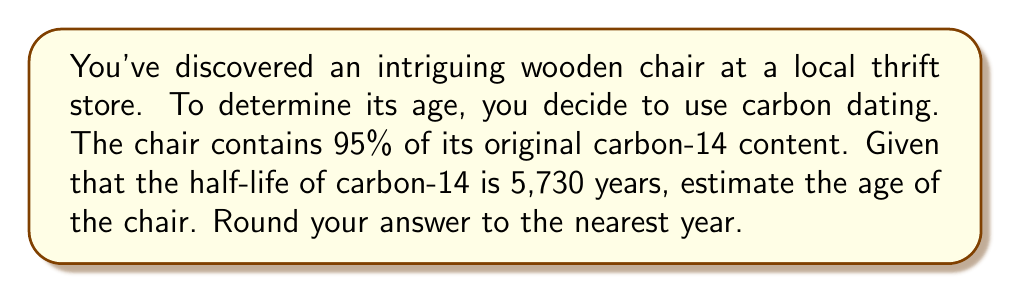Solve this math problem. Let's approach this step-by-step using the radioactive decay model:

1) The general formula for radioactive decay is:

   $$N(t) = N_0 \cdot e^{-\lambda t}$$

   Where:
   $N(t)$ is the amount remaining after time $t$
   $N_0$ is the initial amount
   $\lambda$ is the decay constant
   $t$ is time

2) We're given that 95% of the original carbon-14 remains, so:

   $$\frac{N(t)}{N_0} = 0.95$$

3) Substituting this into our decay formula:

   $$0.95 = e^{-\lambda t}$$

4) To find $\lambda$, we use the half-life formula:

   $$T_{1/2} = \frac{\ln(2)}{\lambda}$$

   $$\lambda = \frac{\ln(2)}{5730}$$

5) Now we can solve for $t$:

   $$\ln(0.95) = -\frac{\ln(2)}{5730} \cdot t$$

   $$t = -\frac{5730 \cdot \ln(0.95)}{\ln(2)}$$

6) Calculate:

   $$t \approx 423.7$$

7) Rounding to the nearest year:

   $$t \approx 424 \text{ years}$$
Answer: 424 years 